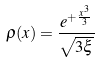<formula> <loc_0><loc_0><loc_500><loc_500>\rho ( x ) = \frac { e ^ { + \frac { x ^ { 3 } } { 3 } } } { \sqrt { 3 \xi } }</formula> 